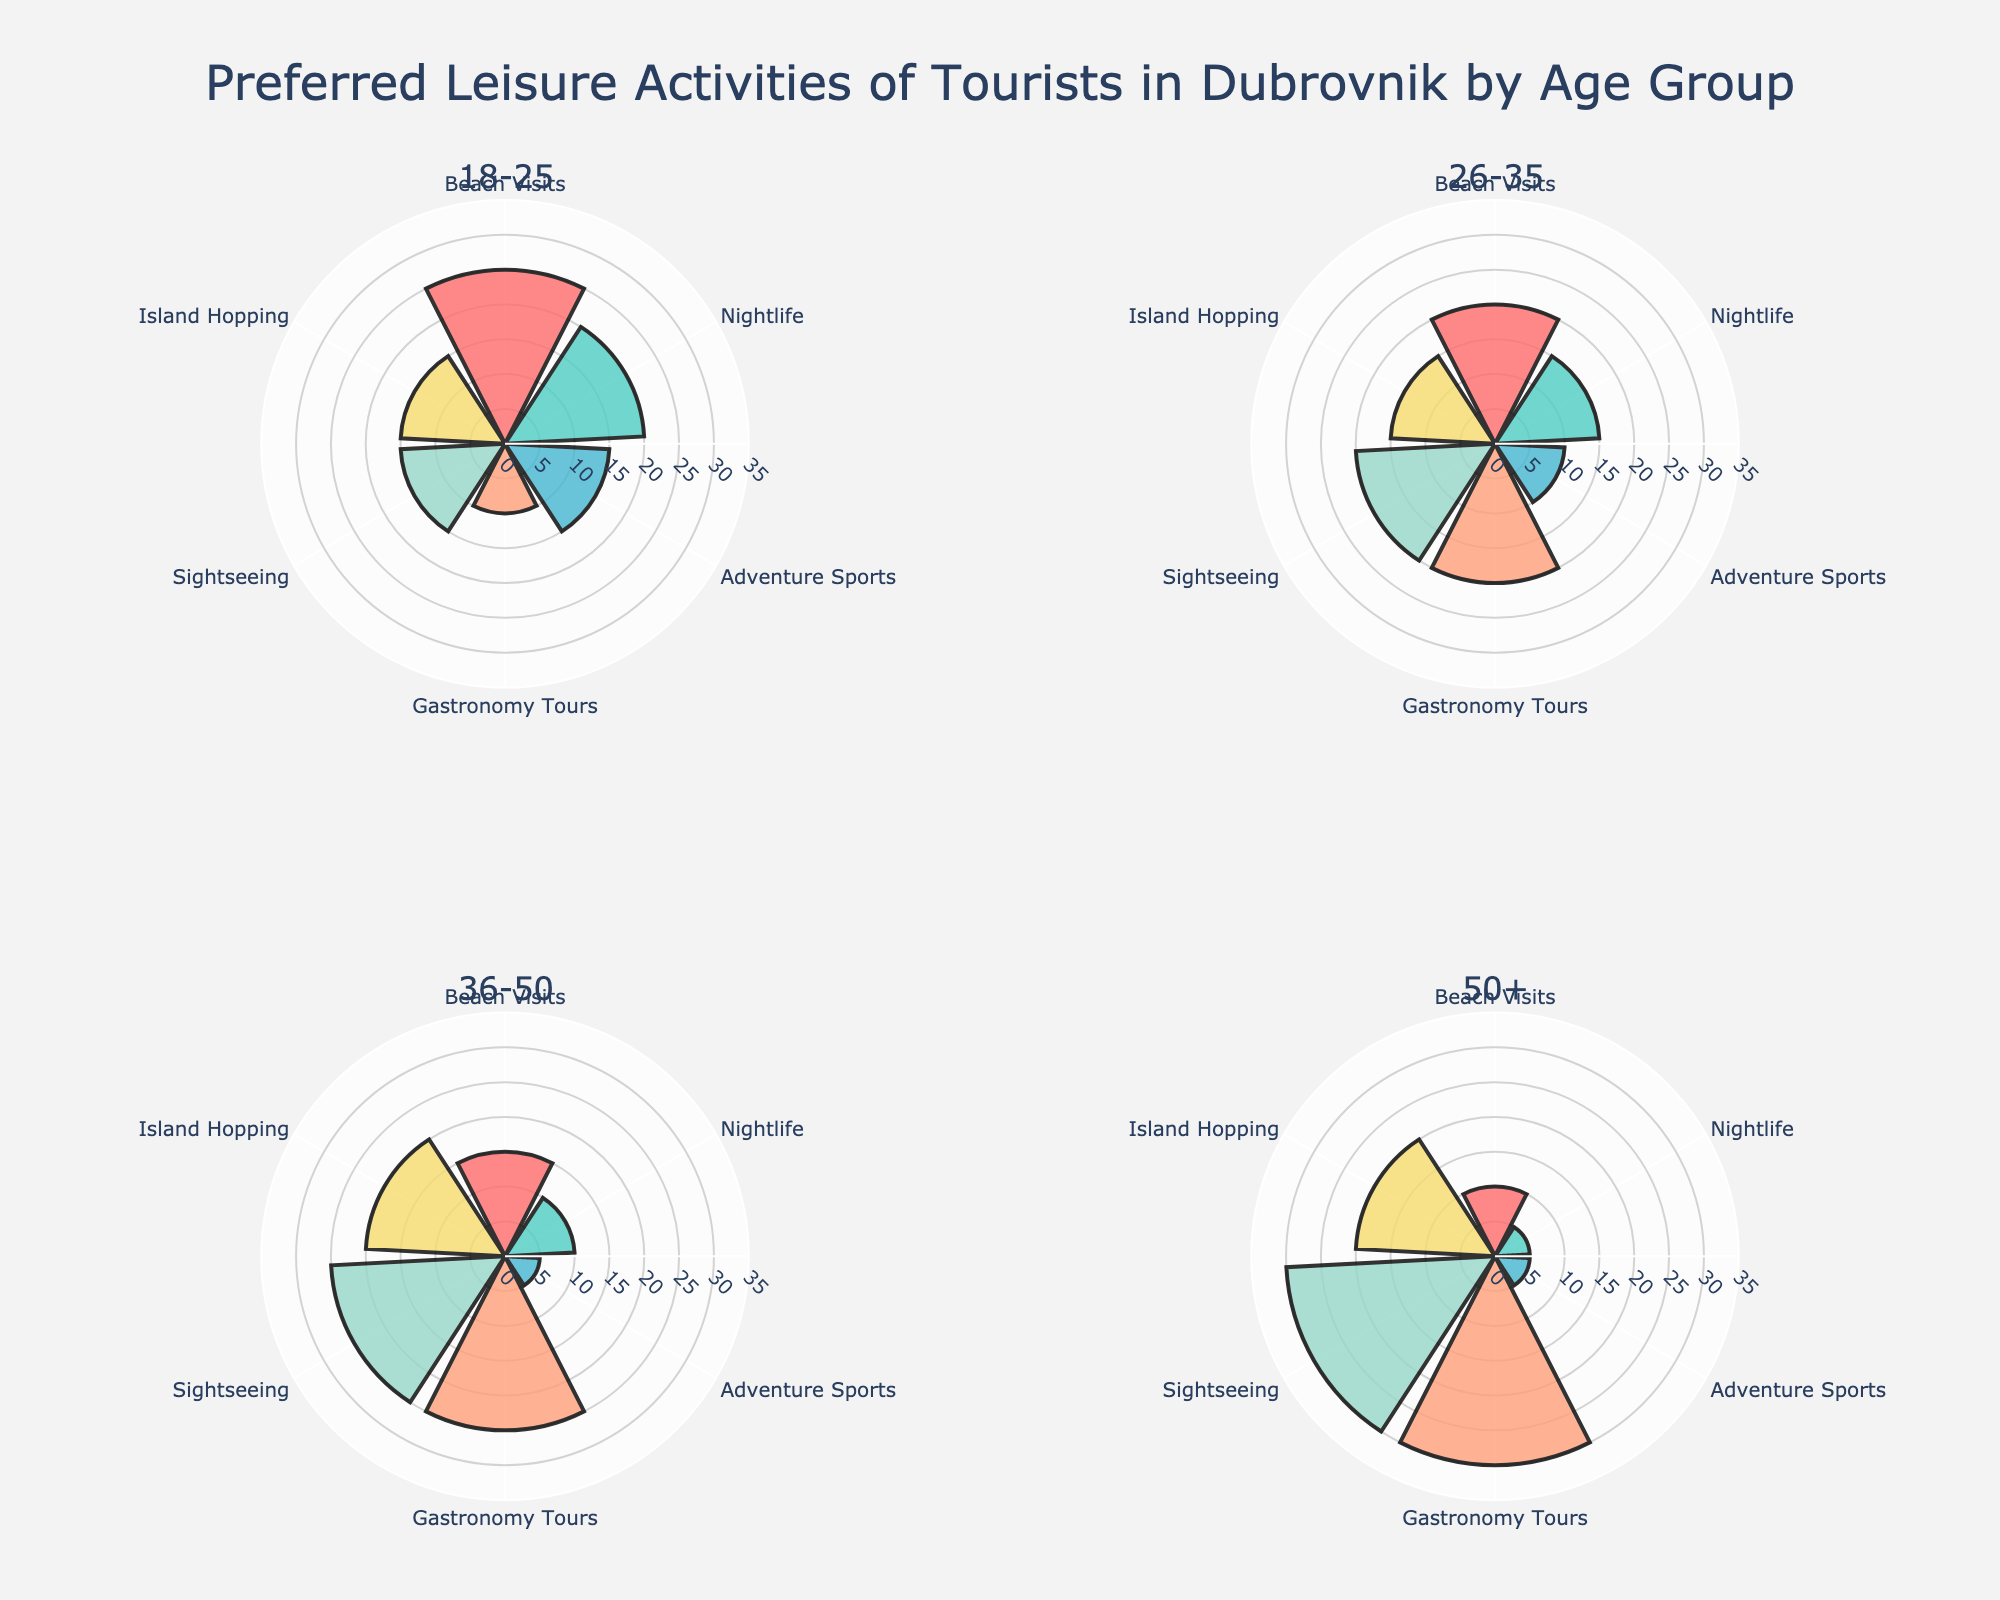What is the most preferred activity for tourists aged 18-25? The segment for tourists aged 18-25 shows the highest percentage for Beach Visits, which is 25%.
Answer: Beach Visits Which age group shows the highest preference for nightlife activities? Among the subplots, the 18-25 age group has the highest segment for Nightlife activities, which is 20%.
Answer: 18-25 What is the least preferred activity for tourists aged 36-50? For the 36-50 age group, the smallest segments are for Adventure Sports and Nightlife, both at 5%.
Answer: Adventure Sports or Nightlife How does the preference for Beach Visits change across different age groups? The subplots show Beach Visits percentages as follows: 18-25 (25%), 26-35 (20%), 36-50 (15%), 50+ (10%). This indicates a decreasing trend with increasing age.
Answer: Decreases with age What is the combined percentage for Gastronomy Tours and Sightseeing for the 26-35 age group? For 26-35 age group, Gastronomy Tours is at 20% and Sightseeing is at 20%. The combined percentage is 20% + 20% = 40%.
Answer: 40% Between which two age groups is the difference in preference for Adventure Sports the greatest? Comparing the subplots, the preference for Adventure Sports is: 18-25 (15%), 26-35 (10%), 36-50 (5%), 50+ (5%). The greatest difference is between 18-25 and both 36-50 and 50+ (15% - 5% = 10%).
Answer: 18-25 and 36-50 or 50+ Which age group has the highest preference for Island Hopping? The 36-50 and 50+ age groups both have a segment showing 20% preference for Island Hopping.
Answer: 36-50 or 50+ What percentage of tourists aged 50+ prefer Sightseeing combined with Gastronomy Tours? For the 50+ age group, Sightseeing is 30% and Gastronomy Tours is 30%. The combined percentage is 30% + 30% = 60%.
Answer: 60% Which activity shows the smallest variation in preference across all age groups? Each age group's activities should be compared. Adventure Sports have preferences as follows: 18-25 (15%), 26-35 (10%), 36-50 (5%), 50+ (5%), showing the smallest range difference of 10%.
Answer: Adventure Sports 